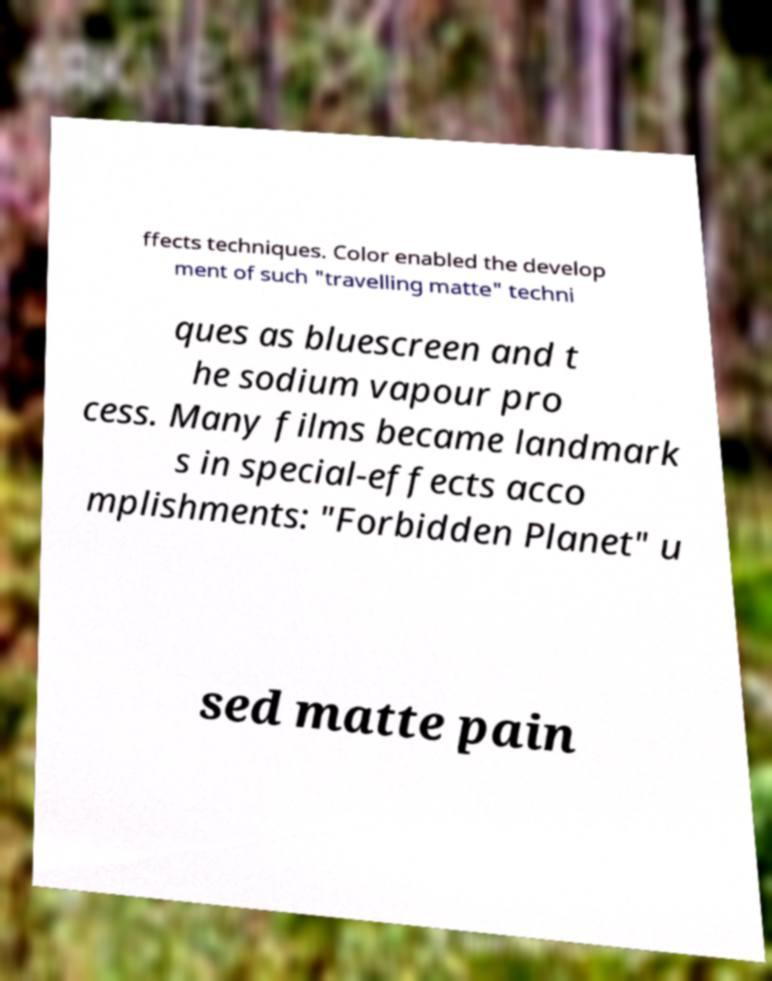Please read and relay the text visible in this image. What does it say? ffects techniques. Color enabled the develop ment of such "travelling matte" techni ques as bluescreen and t he sodium vapour pro cess. Many films became landmark s in special-effects acco mplishments: "Forbidden Planet" u sed matte pain 